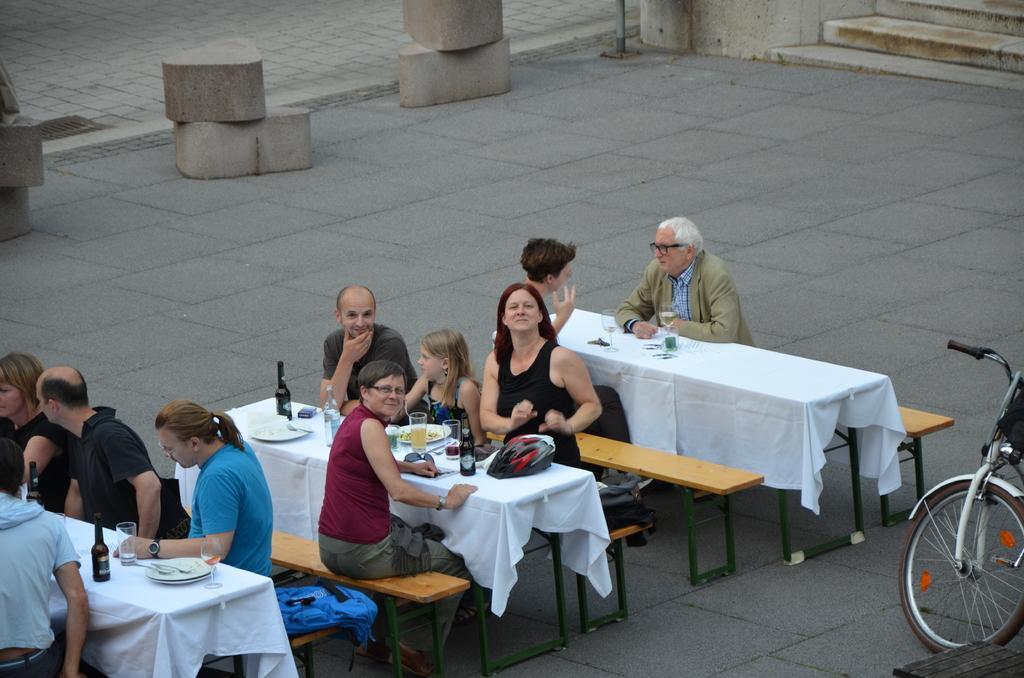Could you give a brief overview of what you see in this image? In this image i can see a group of people are sitting on a bench in front of a table. On the table we have a bag and a couple of objects on it. I can also see there is a bicycle on the ground. 